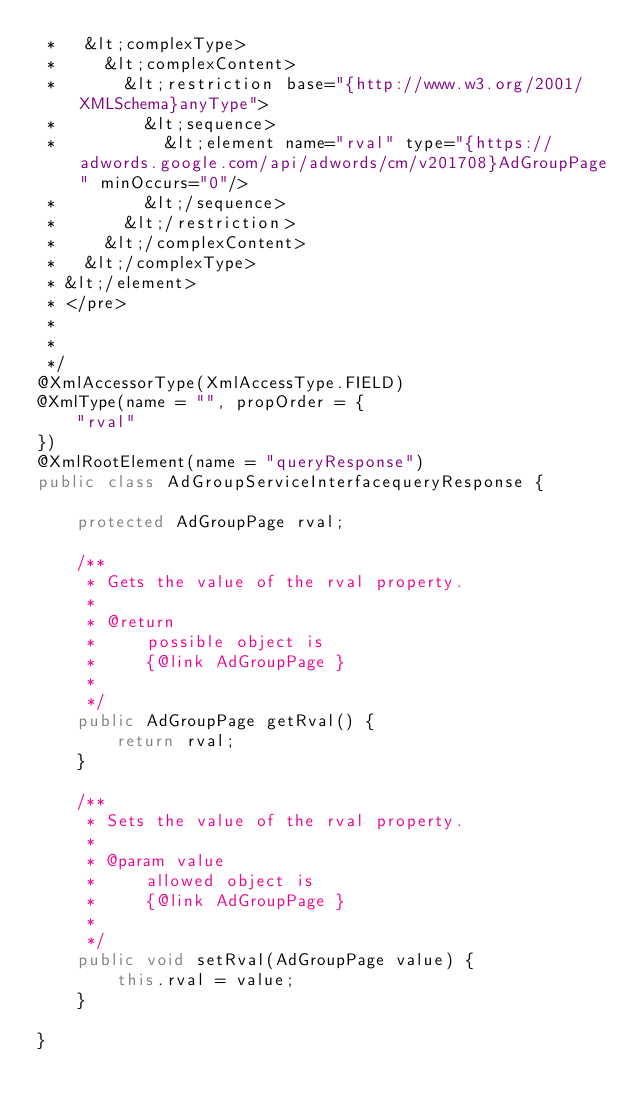<code> <loc_0><loc_0><loc_500><loc_500><_Java_> *   &lt;complexType>
 *     &lt;complexContent>
 *       &lt;restriction base="{http://www.w3.org/2001/XMLSchema}anyType">
 *         &lt;sequence>
 *           &lt;element name="rval" type="{https://adwords.google.com/api/adwords/cm/v201708}AdGroupPage" minOccurs="0"/>
 *         &lt;/sequence>
 *       &lt;/restriction>
 *     &lt;/complexContent>
 *   &lt;/complexType>
 * &lt;/element>
 * </pre>
 * 
 * 
 */
@XmlAccessorType(XmlAccessType.FIELD)
@XmlType(name = "", propOrder = {
    "rval"
})
@XmlRootElement(name = "queryResponse")
public class AdGroupServiceInterfacequeryResponse {

    protected AdGroupPage rval;

    /**
     * Gets the value of the rval property.
     * 
     * @return
     *     possible object is
     *     {@link AdGroupPage }
     *     
     */
    public AdGroupPage getRval() {
        return rval;
    }

    /**
     * Sets the value of the rval property.
     * 
     * @param value
     *     allowed object is
     *     {@link AdGroupPage }
     *     
     */
    public void setRval(AdGroupPage value) {
        this.rval = value;
    }

}
</code> 